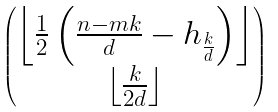<formula> <loc_0><loc_0><loc_500><loc_500>\begin{pmatrix} \left \lfloor \frac { 1 } { 2 } \left ( \frac { n - m k } { d } - h _ { \frac { k } { d } } \right ) \right \rfloor \\ \left \lfloor \frac { k } { 2 d } \right \rfloor \end{pmatrix}</formula> 